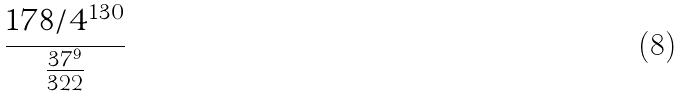<formula> <loc_0><loc_0><loc_500><loc_500>\frac { 1 7 8 / 4 ^ { 1 3 0 } } { \frac { 3 7 ^ { 9 } } { 3 2 2 } }</formula> 